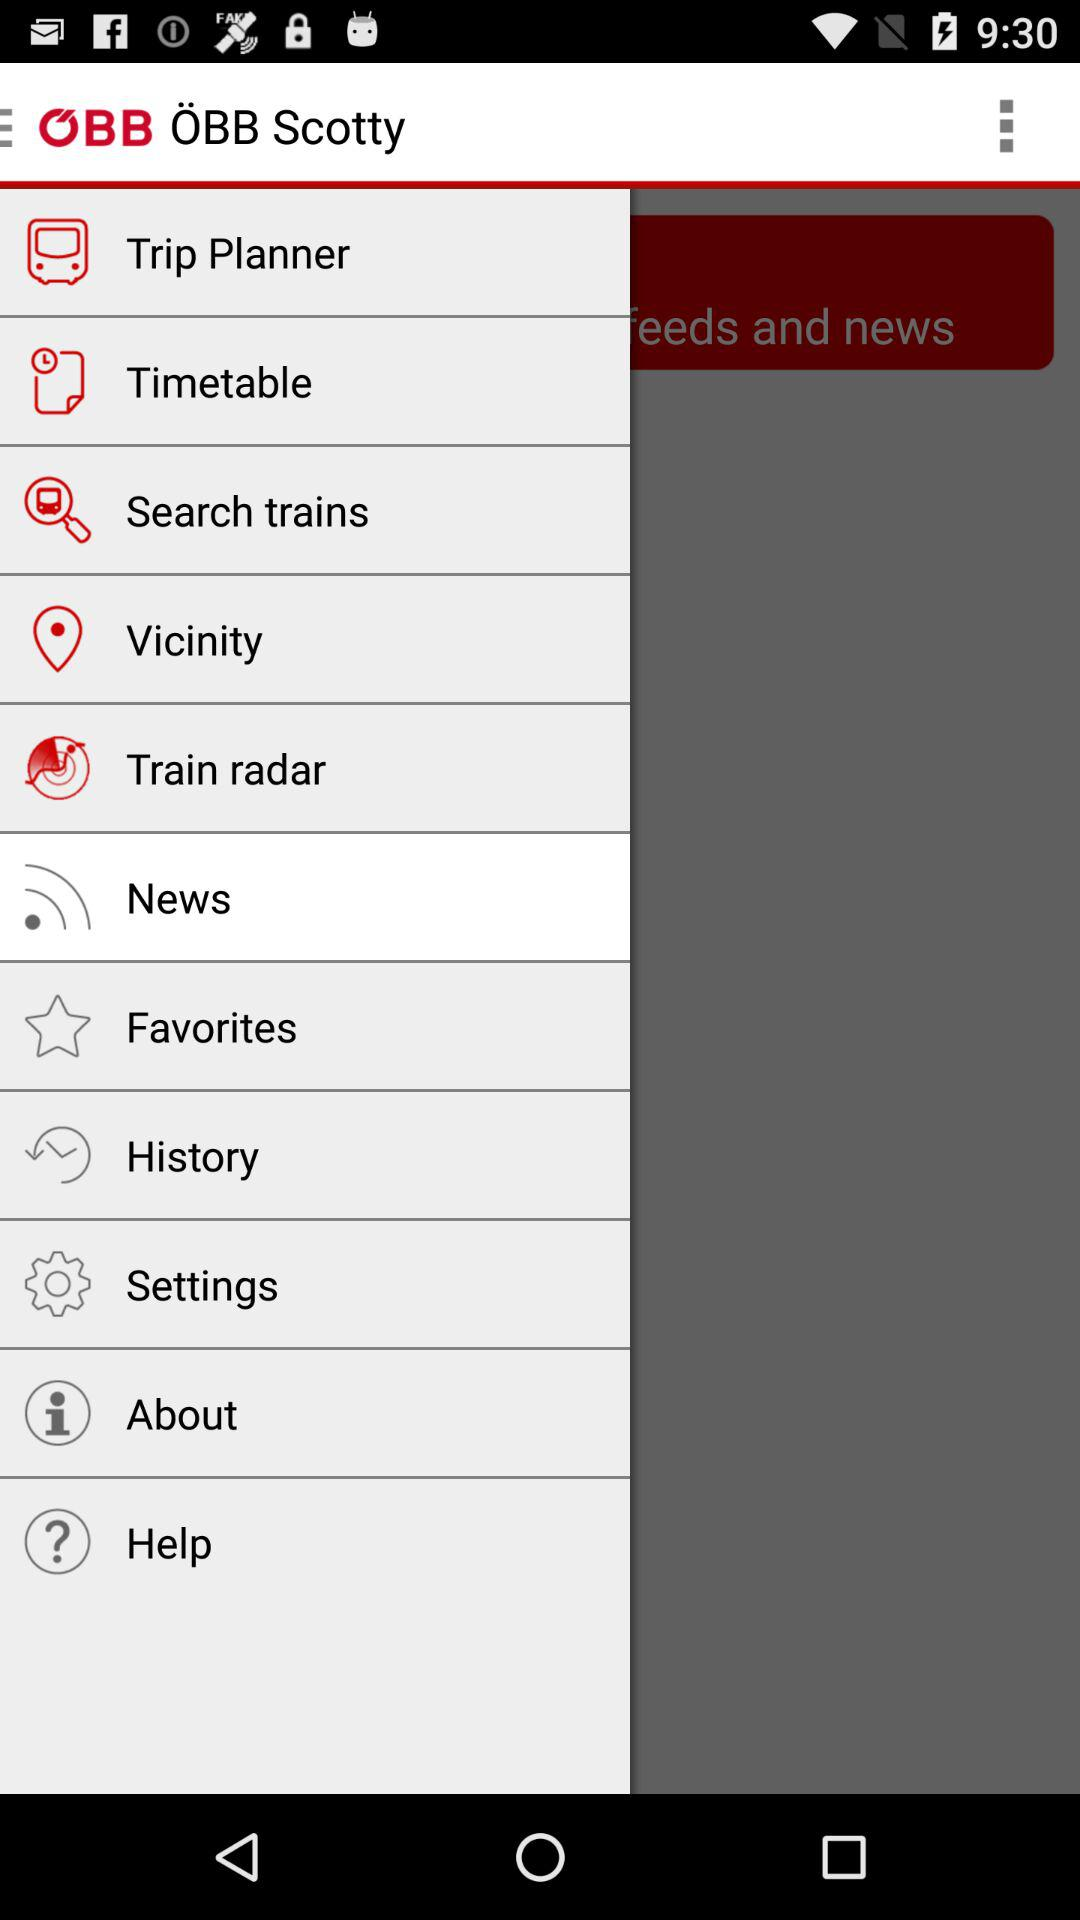What is the application name? The application name is "ÖBB Scotty". 